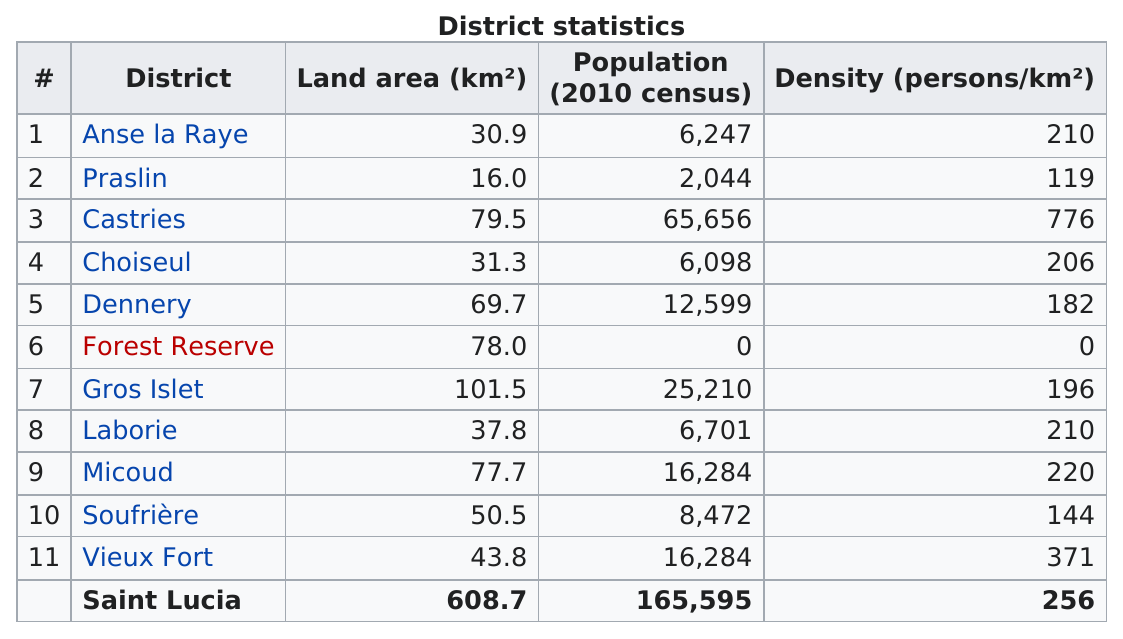Outline some significant characteristics in this image. It is estimated that 16,284 individuals reside in Micoud. Choiseul has the highest population among the districts, followed by Anse la Raye. Saint Lucia has five districts with a population density below 200 persons per square kilometer. The district of Micoud is larger than the district of Dennery. Castries district has the highest density out of all the districts. 